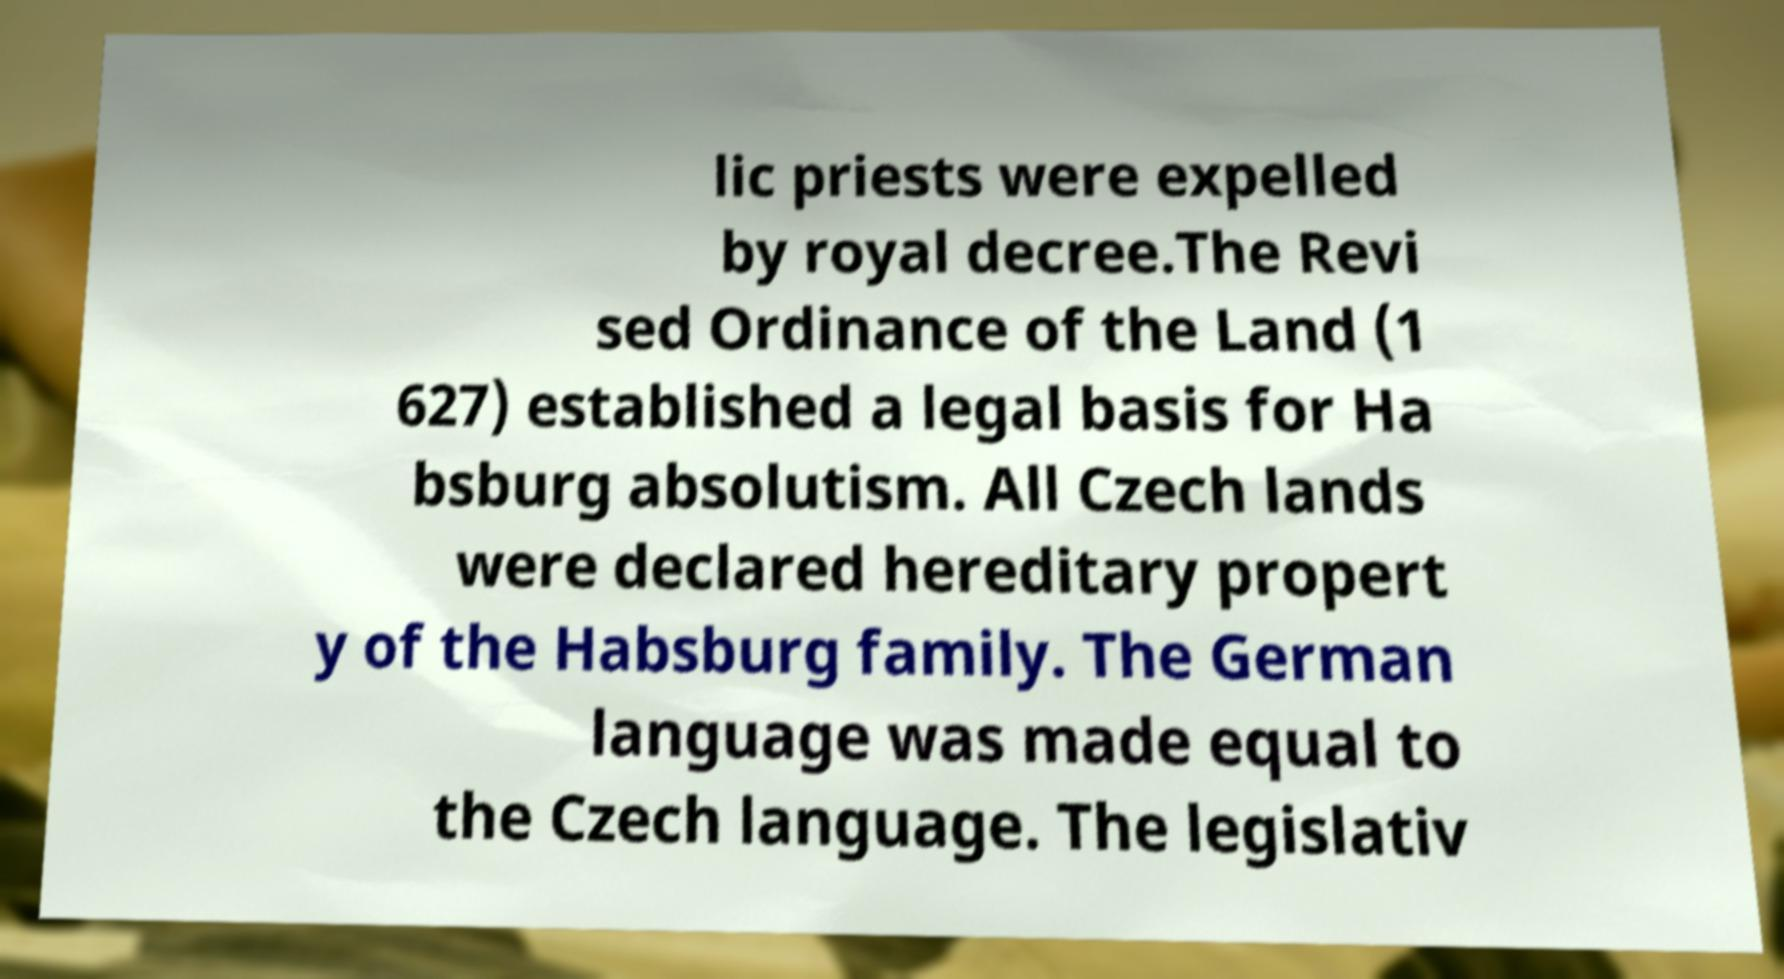Can you read and provide the text displayed in the image?This photo seems to have some interesting text. Can you extract and type it out for me? lic priests were expelled by royal decree.The Revi sed Ordinance of the Land (1 627) established a legal basis for Ha bsburg absolutism. All Czech lands were declared hereditary propert y of the Habsburg family. The German language was made equal to the Czech language. The legislativ 